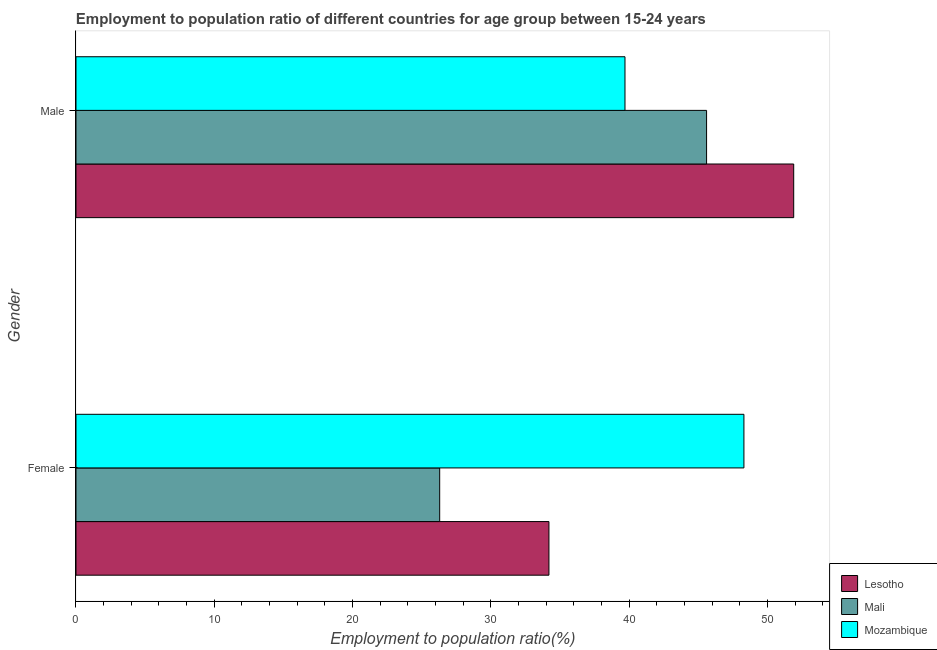How many different coloured bars are there?
Keep it short and to the point. 3. Are the number of bars on each tick of the Y-axis equal?
Your answer should be very brief. Yes. How many bars are there on the 2nd tick from the top?
Your answer should be very brief. 3. How many bars are there on the 1st tick from the bottom?
Your response must be concise. 3. What is the label of the 1st group of bars from the top?
Your answer should be compact. Male. What is the employment to population ratio(male) in Mozambique?
Keep it short and to the point. 39.7. Across all countries, what is the maximum employment to population ratio(male)?
Ensure brevity in your answer.  51.9. Across all countries, what is the minimum employment to population ratio(male)?
Offer a very short reply. 39.7. In which country was the employment to population ratio(male) maximum?
Provide a short and direct response. Lesotho. In which country was the employment to population ratio(male) minimum?
Ensure brevity in your answer.  Mozambique. What is the total employment to population ratio(female) in the graph?
Keep it short and to the point. 108.8. What is the difference between the employment to population ratio(male) in Lesotho and that in Mozambique?
Offer a very short reply. 12.2. What is the difference between the employment to population ratio(female) in Mali and the employment to population ratio(male) in Mozambique?
Provide a succinct answer. -13.4. What is the average employment to population ratio(male) per country?
Offer a terse response. 45.73. What is the difference between the employment to population ratio(female) and employment to population ratio(male) in Mozambique?
Offer a very short reply. 8.6. What is the ratio of the employment to population ratio(female) in Lesotho to that in Mozambique?
Provide a succinct answer. 0.71. Is the employment to population ratio(male) in Lesotho less than that in Mali?
Your response must be concise. No. In how many countries, is the employment to population ratio(male) greater than the average employment to population ratio(male) taken over all countries?
Ensure brevity in your answer.  1. What does the 2nd bar from the top in Female represents?
Offer a terse response. Mali. What does the 3rd bar from the bottom in Female represents?
Provide a succinct answer. Mozambique. How many bars are there?
Ensure brevity in your answer.  6. Are all the bars in the graph horizontal?
Your response must be concise. Yes. How many countries are there in the graph?
Ensure brevity in your answer.  3. Does the graph contain grids?
Provide a short and direct response. No. Where does the legend appear in the graph?
Offer a terse response. Bottom right. How many legend labels are there?
Keep it short and to the point. 3. What is the title of the graph?
Offer a very short reply. Employment to population ratio of different countries for age group between 15-24 years. What is the Employment to population ratio(%) in Lesotho in Female?
Ensure brevity in your answer.  34.2. What is the Employment to population ratio(%) in Mali in Female?
Offer a very short reply. 26.3. What is the Employment to population ratio(%) of Mozambique in Female?
Offer a terse response. 48.3. What is the Employment to population ratio(%) in Lesotho in Male?
Your answer should be very brief. 51.9. What is the Employment to population ratio(%) in Mali in Male?
Your answer should be very brief. 45.6. What is the Employment to population ratio(%) in Mozambique in Male?
Offer a terse response. 39.7. Across all Gender, what is the maximum Employment to population ratio(%) in Lesotho?
Offer a very short reply. 51.9. Across all Gender, what is the maximum Employment to population ratio(%) of Mali?
Offer a very short reply. 45.6. Across all Gender, what is the maximum Employment to population ratio(%) in Mozambique?
Your answer should be compact. 48.3. Across all Gender, what is the minimum Employment to population ratio(%) in Lesotho?
Offer a terse response. 34.2. Across all Gender, what is the minimum Employment to population ratio(%) of Mali?
Your answer should be very brief. 26.3. Across all Gender, what is the minimum Employment to population ratio(%) of Mozambique?
Provide a short and direct response. 39.7. What is the total Employment to population ratio(%) in Lesotho in the graph?
Keep it short and to the point. 86.1. What is the total Employment to population ratio(%) in Mali in the graph?
Give a very brief answer. 71.9. What is the difference between the Employment to population ratio(%) of Lesotho in Female and that in Male?
Offer a terse response. -17.7. What is the difference between the Employment to population ratio(%) in Mali in Female and that in Male?
Keep it short and to the point. -19.3. What is the difference between the Employment to population ratio(%) in Mali in Female and the Employment to population ratio(%) in Mozambique in Male?
Your response must be concise. -13.4. What is the average Employment to population ratio(%) in Lesotho per Gender?
Give a very brief answer. 43.05. What is the average Employment to population ratio(%) of Mali per Gender?
Give a very brief answer. 35.95. What is the average Employment to population ratio(%) of Mozambique per Gender?
Ensure brevity in your answer.  44. What is the difference between the Employment to population ratio(%) of Lesotho and Employment to population ratio(%) of Mozambique in Female?
Ensure brevity in your answer.  -14.1. What is the ratio of the Employment to population ratio(%) in Lesotho in Female to that in Male?
Ensure brevity in your answer.  0.66. What is the ratio of the Employment to population ratio(%) of Mali in Female to that in Male?
Your answer should be very brief. 0.58. What is the ratio of the Employment to population ratio(%) of Mozambique in Female to that in Male?
Keep it short and to the point. 1.22. What is the difference between the highest and the second highest Employment to population ratio(%) in Mali?
Your answer should be very brief. 19.3. What is the difference between the highest and the lowest Employment to population ratio(%) of Lesotho?
Your answer should be very brief. 17.7. What is the difference between the highest and the lowest Employment to population ratio(%) in Mali?
Your answer should be compact. 19.3. What is the difference between the highest and the lowest Employment to population ratio(%) of Mozambique?
Your response must be concise. 8.6. 